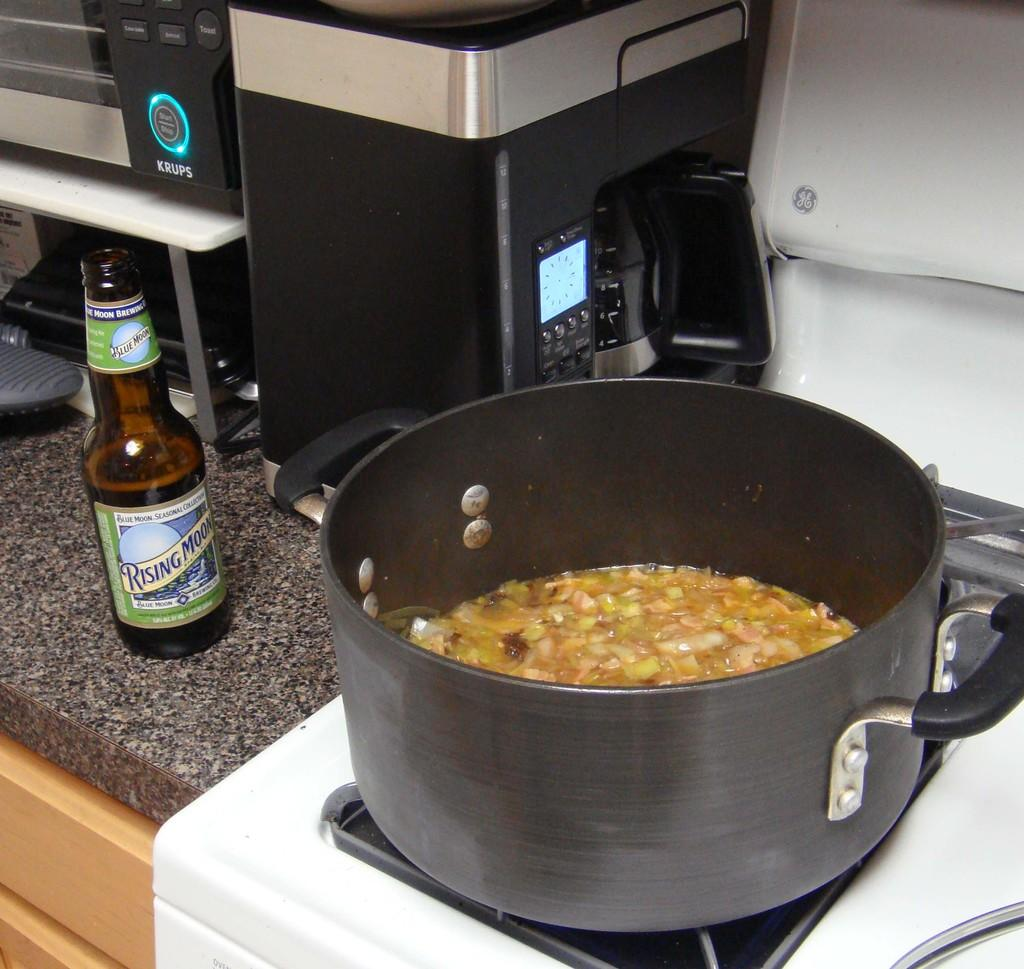Provide a one-sentence caption for the provided image. A glass Rising Moon beer bottle sits next to a boiling pot. 